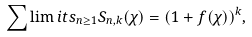Convert formula to latex. <formula><loc_0><loc_0><loc_500><loc_500>\sum \lim i t s _ { n \geq 1 } S _ { n , k } ( \chi ) = ( 1 + f ( \chi ) ) ^ { k } ,</formula> 